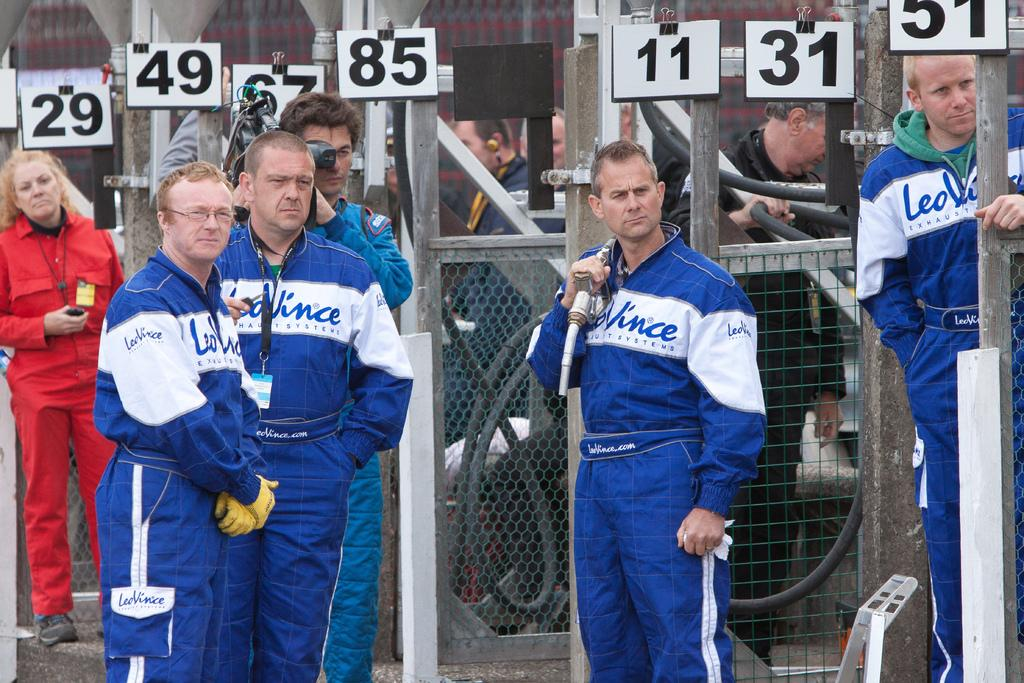<image>
Write a terse but informative summary of the picture. a few men with jackets on that say Vince 